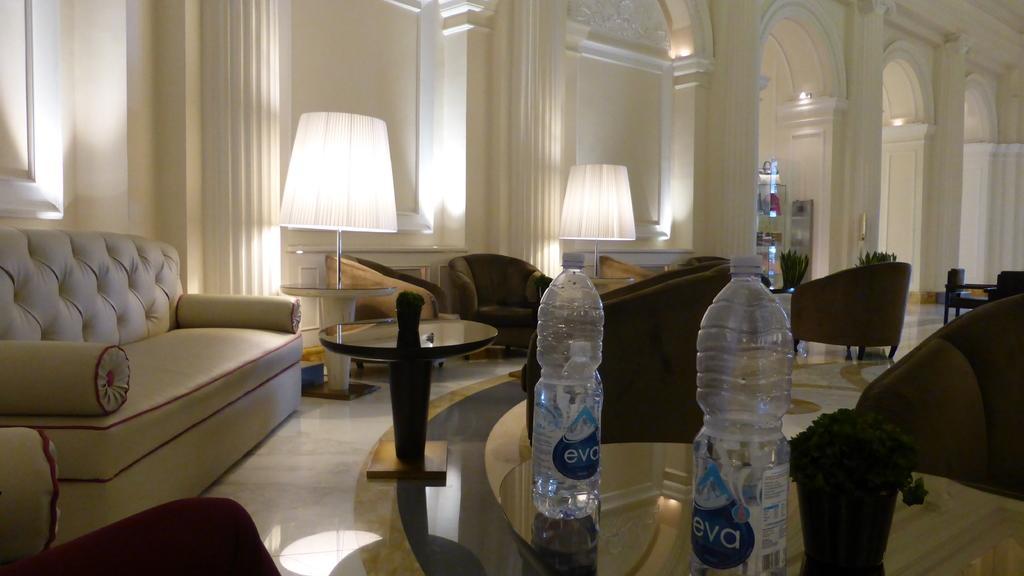Describe this image in one or two sentences. The picture is taken inside the hall in which there are sofas,chairs,lamps,table on which there are two bottles. At the background there is a wall. 